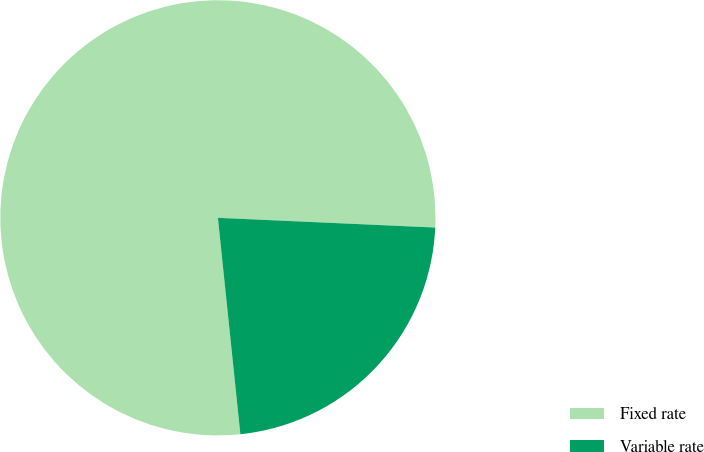Convert chart to OTSL. <chart><loc_0><loc_0><loc_500><loc_500><pie_chart><fcel>Fixed rate<fcel>Variable rate<nl><fcel>77.36%<fcel>22.64%<nl></chart> 